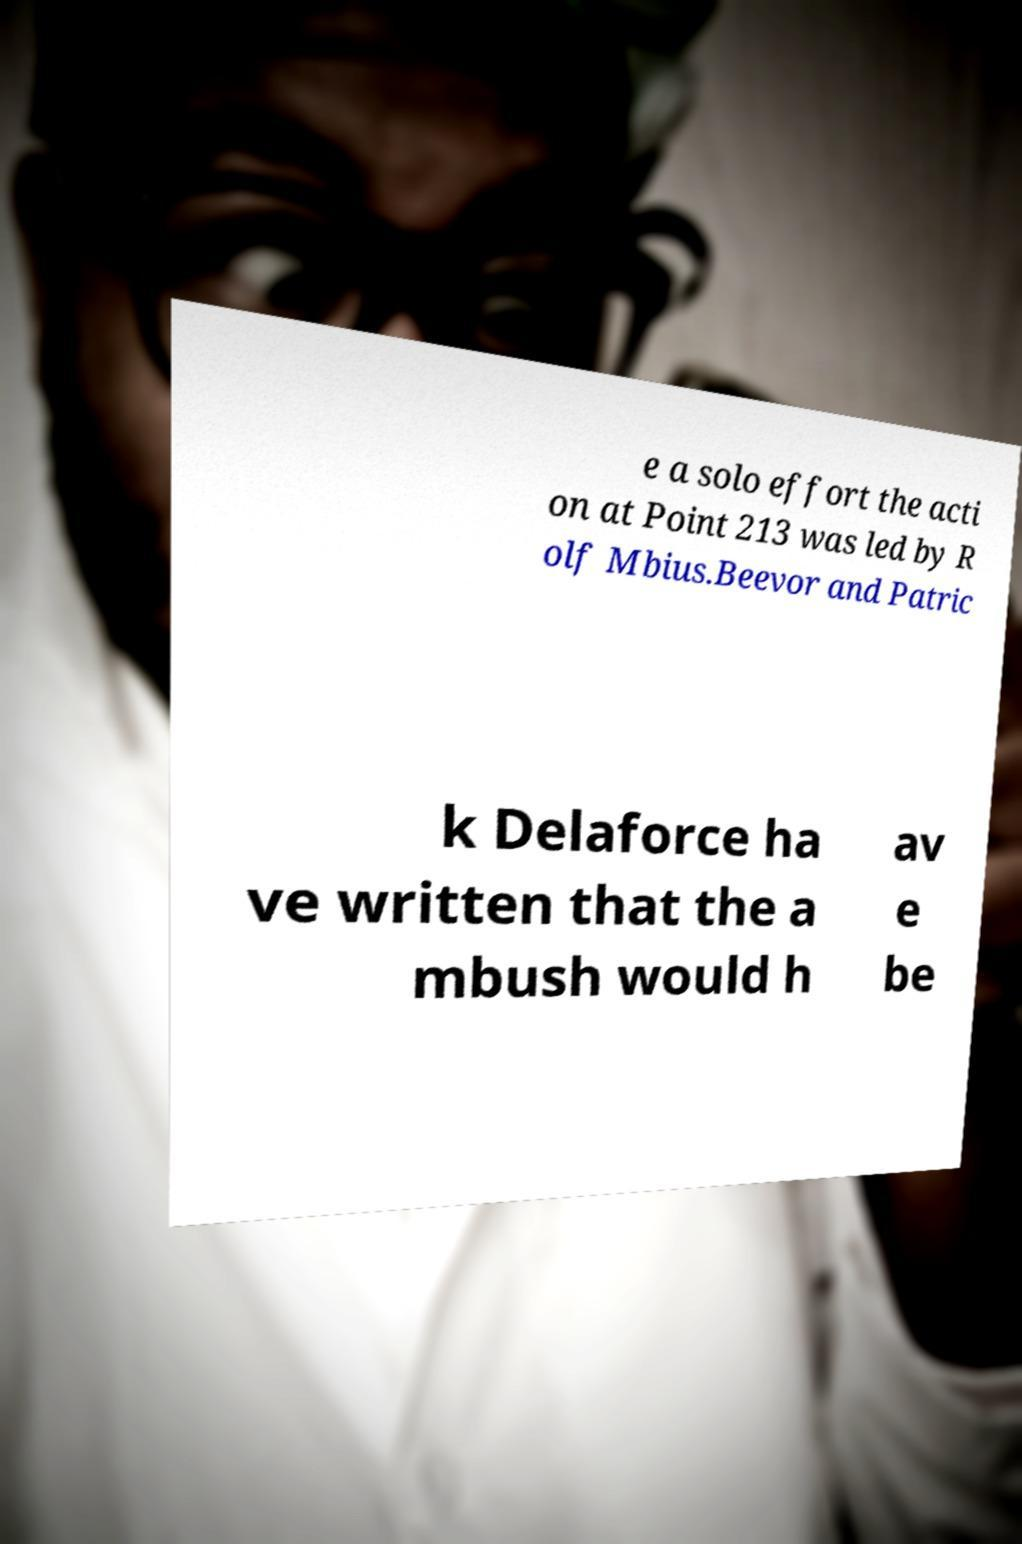Please identify and transcribe the text found in this image. e a solo effort the acti on at Point 213 was led by R olf Mbius.Beevor and Patric k Delaforce ha ve written that the a mbush would h av e be 